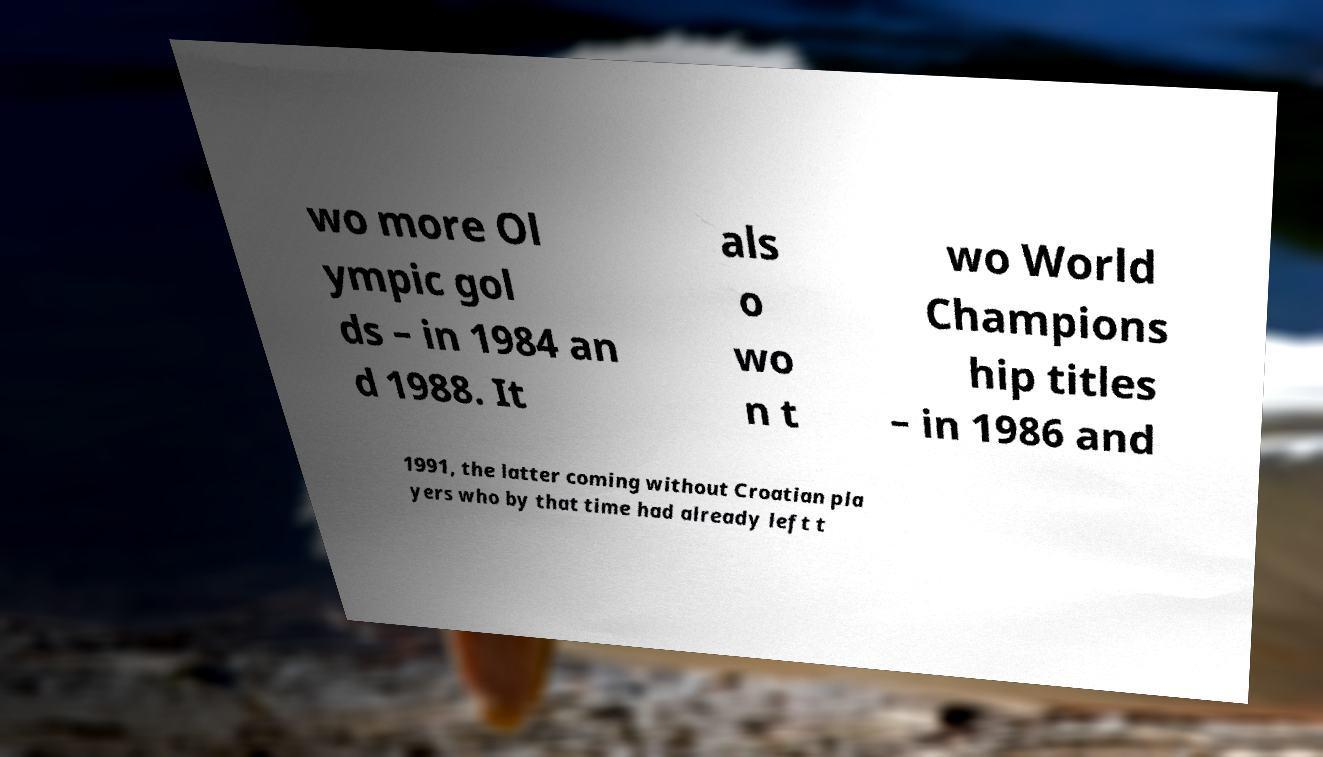There's text embedded in this image that I need extracted. Can you transcribe it verbatim? wo more Ol ympic gol ds – in 1984 an d 1988. It als o wo n t wo World Champions hip titles – in 1986 and 1991, the latter coming without Croatian pla yers who by that time had already left t 